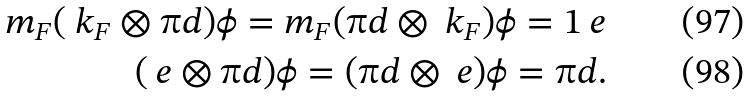<formula> <loc_0><loc_0><loc_500><loc_500>m _ { F } ( \ k _ { F } \otimes \i d ) \phi = m _ { F } ( \i d \otimes \ k _ { F } ) \phi = 1 \ e \\ ( \ e \otimes \i d ) \phi = ( \i d \otimes \ e ) \phi = \i d .</formula> 